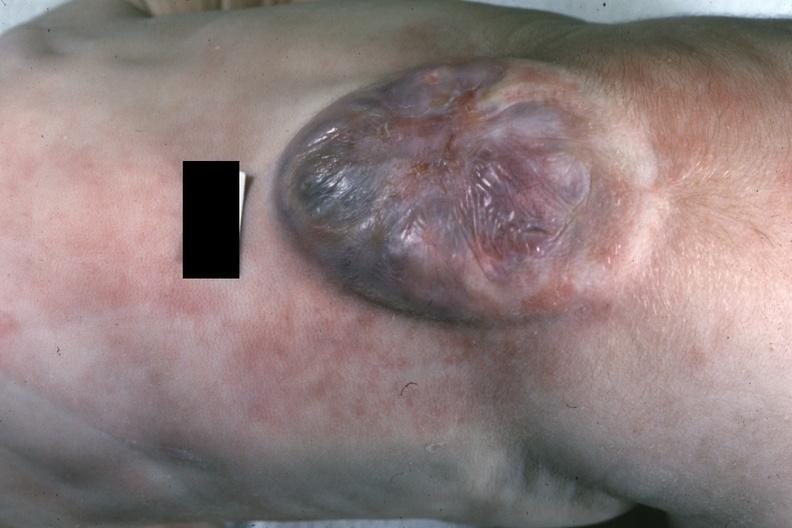does this image show close-up excellent example?
Answer the question using a single word or phrase. Yes 